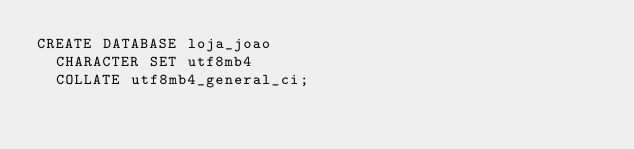<code> <loc_0><loc_0><loc_500><loc_500><_SQL_>CREATE DATABASE loja_joao
  CHARACTER SET utf8mb4
  COLLATE utf8mb4_general_ci;
  </code> 